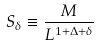Convert formula to latex. <formula><loc_0><loc_0><loc_500><loc_500>S _ { \delta } \equiv \frac { M } { L ^ { 1 + \Delta + \delta } }</formula> 